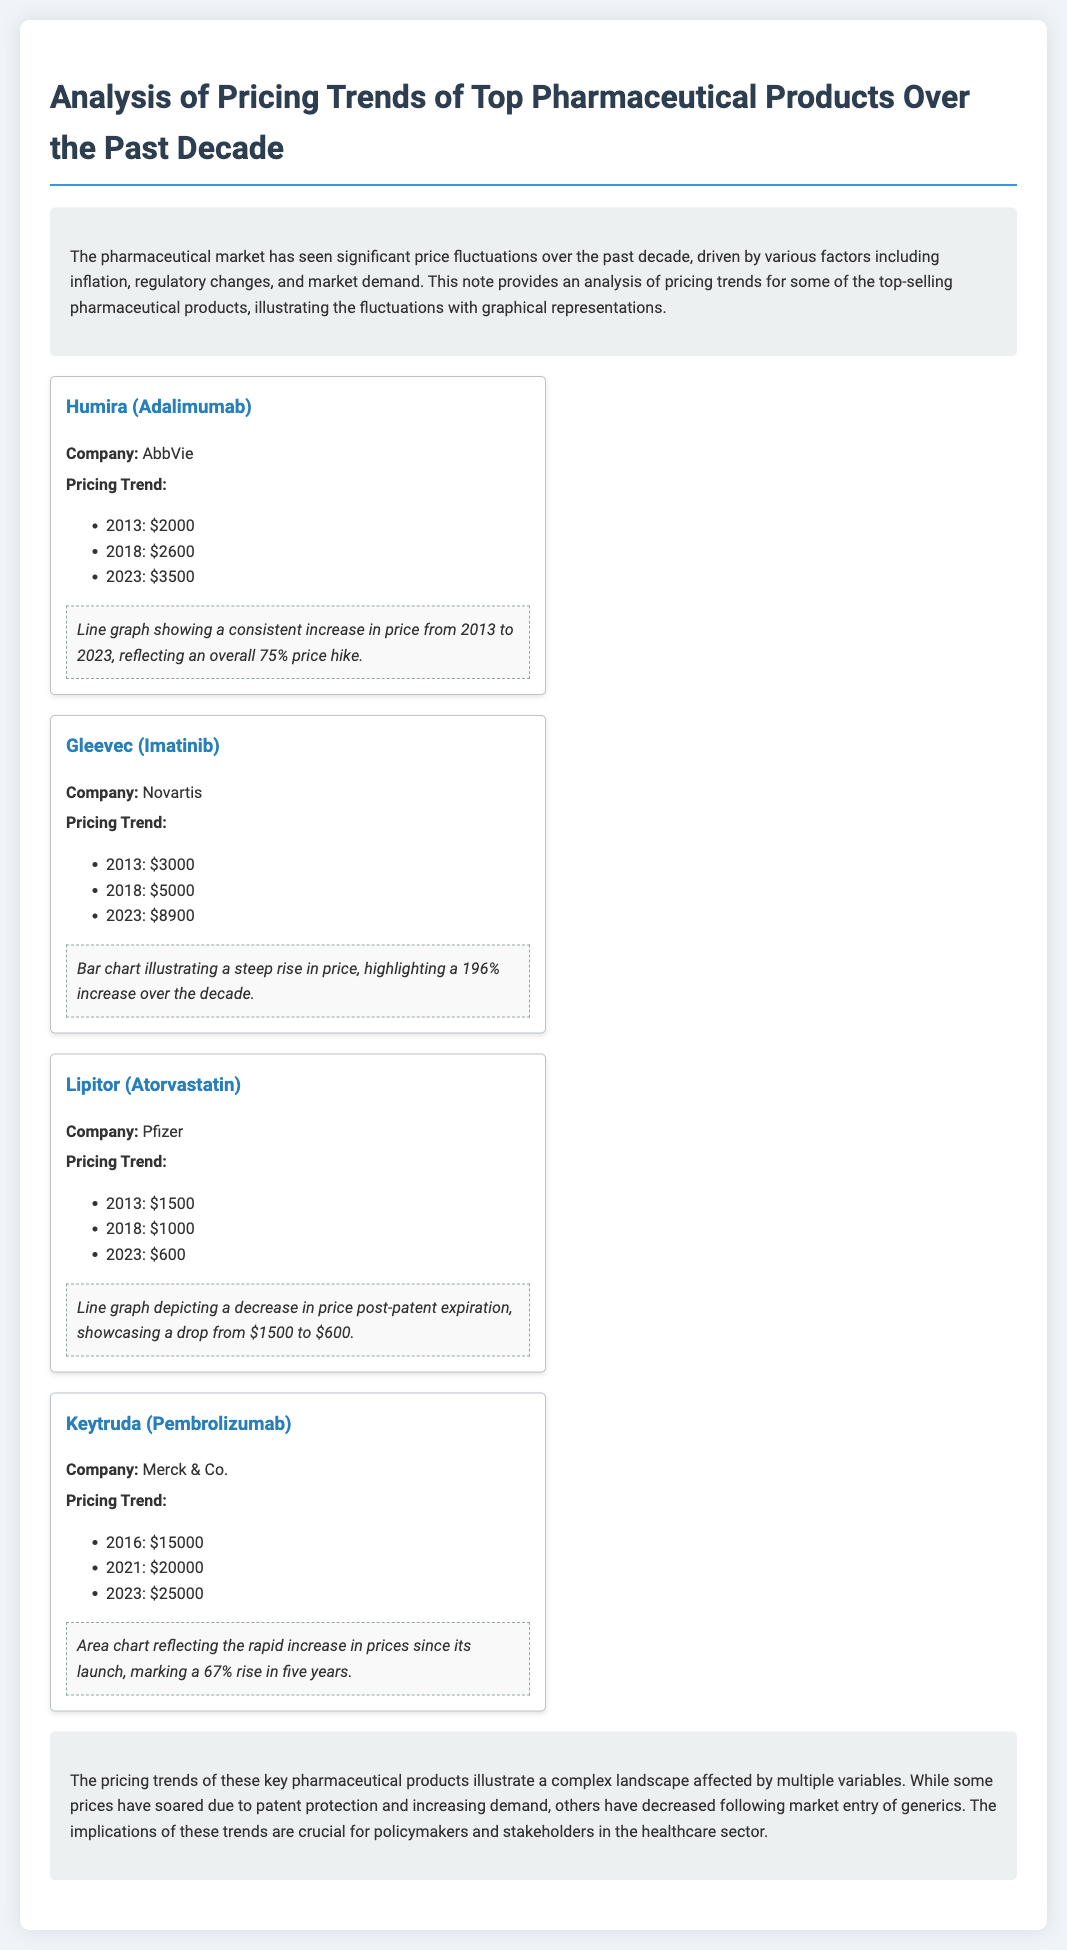What was the price of Humira in 2013? The document lists Humira's price in 2013 as $2000.
Answer: $2000 What percentage increase did Gleevec experience from 2013 to 2023? Gleevec's price increased from $3000 in 2013 to $8900 in 2023, which is a 196% increase.
Answer: 196% What is the 2023 price of Keytruda? According to the pricing trend, the price of Keytruda in 2023 is $25000.
Answer: $25000 Which company produces Lipitor? The document specifies that Lipitor is produced by Pfizer.
Answer: Pfizer What type of graph illustrates the price change of Humira? The document refers to a line graph showing a consistent increase in Humira's price.
Answer: Line graph What price trend does Lipitor show after patent expiration? The document indicates that Lipitor's price decreased after patent expiration.
Answer: Decrease In what year did Keytruda launch? The document provides pricing data for Keytruda starting in 2016, indicating it launched in that year.
Answer: 2016 How much was Gleevec priced in 2018? The document states that Gleevec was priced at $5000 in 2018.
Answer: $5000 What is the overall price increase of Humira from 2013 to 2023? The document mentions an overall price increase of 75% for Humira from 2013 to 2023.
Answer: 75% 